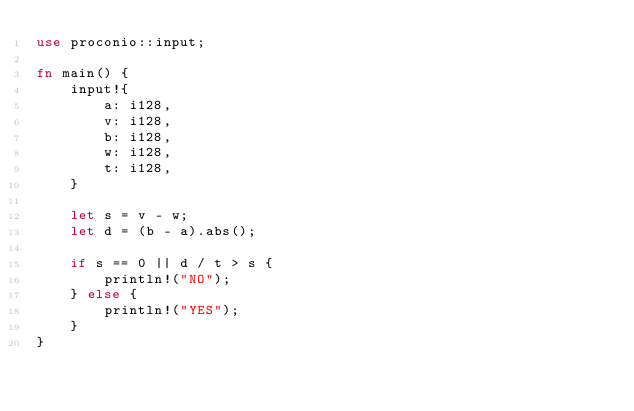<code> <loc_0><loc_0><loc_500><loc_500><_Rust_>use proconio::input;

fn main() {
    input!{
        a: i128,
        v: i128,
        b: i128,
        w: i128,
        t: i128,
    }
    
    let s = v - w;
    let d = (b - a).abs();

    if s == 0 || d / t > s {
        println!("NO");
    } else {
        println!("YES");
    }
}
</code> 